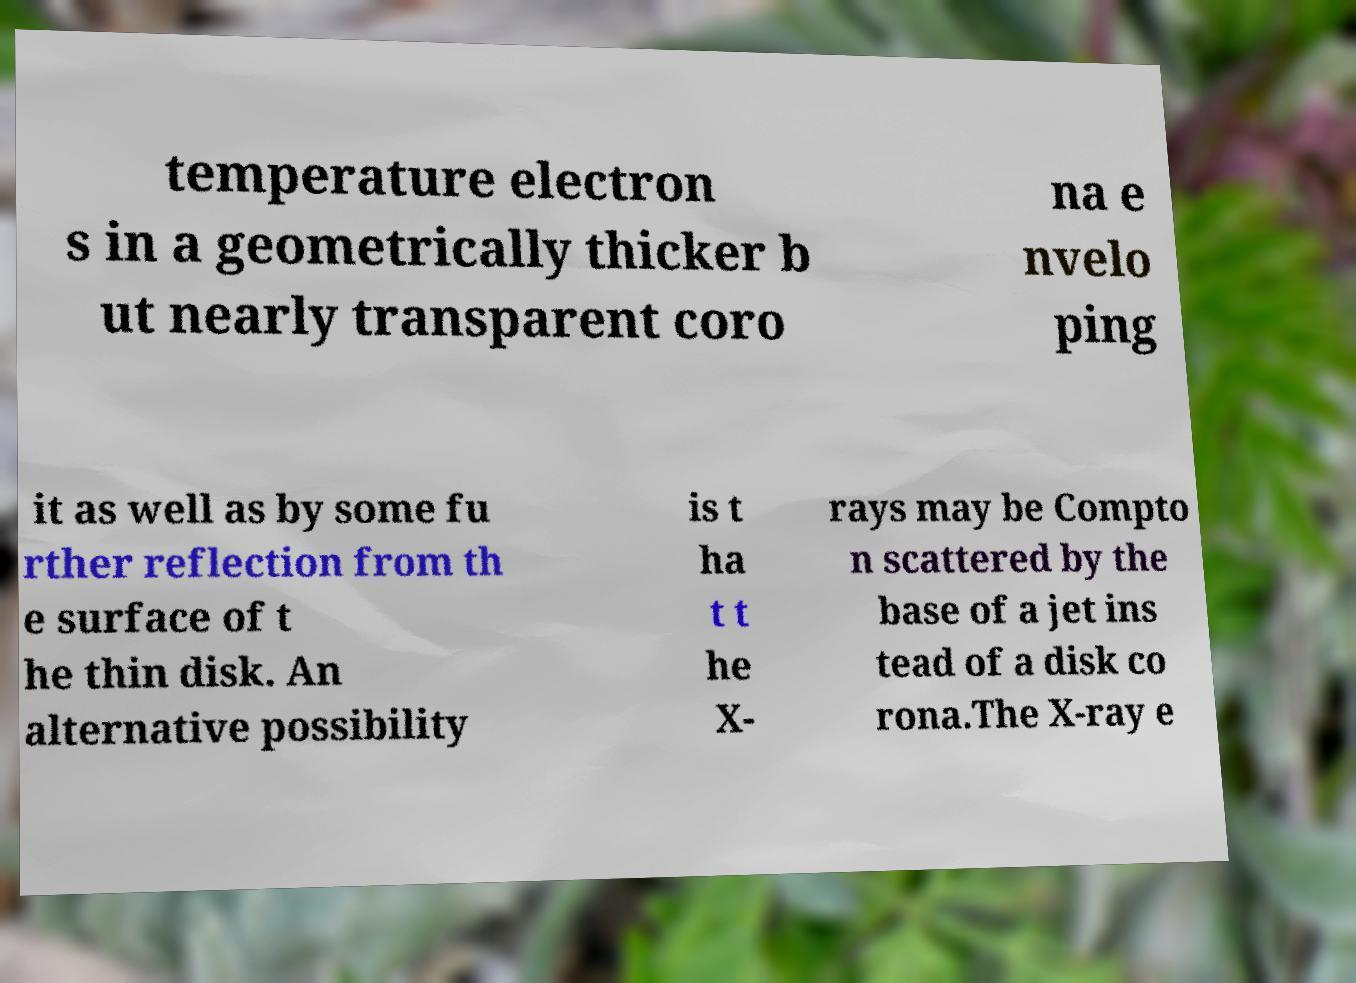What messages or text are displayed in this image? I need them in a readable, typed format. temperature electron s in a geometrically thicker b ut nearly transparent coro na e nvelo ping it as well as by some fu rther reflection from th e surface of t he thin disk. An alternative possibility is t ha t t he X- rays may be Compto n scattered by the base of a jet ins tead of a disk co rona.The X-ray e 